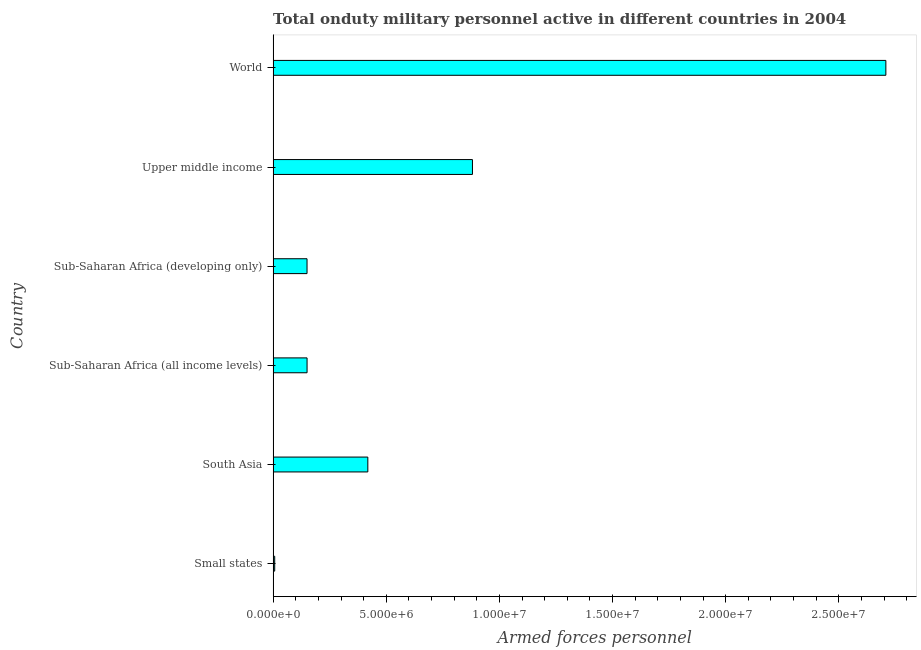Does the graph contain any zero values?
Make the answer very short. No. Does the graph contain grids?
Offer a terse response. No. What is the title of the graph?
Give a very brief answer. Total onduty military personnel active in different countries in 2004. What is the label or title of the X-axis?
Provide a succinct answer. Armed forces personnel. What is the label or title of the Y-axis?
Your response must be concise. Country. What is the number of armed forces personnel in Upper middle income?
Provide a short and direct response. 8.81e+06. Across all countries, what is the maximum number of armed forces personnel?
Your answer should be very brief. 2.71e+07. Across all countries, what is the minimum number of armed forces personnel?
Your answer should be compact. 7.01e+04. In which country was the number of armed forces personnel maximum?
Your answer should be compact. World. In which country was the number of armed forces personnel minimum?
Provide a succinct answer. Small states. What is the sum of the number of armed forces personnel?
Your answer should be very brief. 4.31e+07. What is the difference between the number of armed forces personnel in Sub-Saharan Africa (developing only) and World?
Provide a succinct answer. -2.56e+07. What is the average number of armed forces personnel per country?
Ensure brevity in your answer.  7.19e+06. What is the median number of armed forces personnel?
Ensure brevity in your answer.  2.84e+06. In how many countries, is the number of armed forces personnel greater than 2000000 ?
Your answer should be very brief. 3. What is the ratio of the number of armed forces personnel in South Asia to that in Upper middle income?
Keep it short and to the point. 0.47. Is the number of armed forces personnel in Small states less than that in Upper middle income?
Give a very brief answer. Yes. Is the difference between the number of armed forces personnel in Sub-Saharan Africa (all income levels) and Upper middle income greater than the difference between any two countries?
Make the answer very short. No. What is the difference between the highest and the second highest number of armed forces personnel?
Provide a short and direct response. 1.83e+07. Is the sum of the number of armed forces personnel in South Asia and Upper middle income greater than the maximum number of armed forces personnel across all countries?
Make the answer very short. No. What is the difference between the highest and the lowest number of armed forces personnel?
Your answer should be compact. 2.70e+07. How many bars are there?
Make the answer very short. 6. What is the Armed forces personnel in Small states?
Provide a succinct answer. 7.01e+04. What is the Armed forces personnel in South Asia?
Ensure brevity in your answer.  4.19e+06. What is the Armed forces personnel in Sub-Saharan Africa (all income levels)?
Provide a short and direct response. 1.50e+06. What is the Armed forces personnel of Sub-Saharan Africa (developing only)?
Make the answer very short. 1.50e+06. What is the Armed forces personnel in Upper middle income?
Your answer should be compact. 8.81e+06. What is the Armed forces personnel in World?
Provide a succinct answer. 2.71e+07. What is the difference between the Armed forces personnel in Small states and South Asia?
Offer a very short reply. -4.12e+06. What is the difference between the Armed forces personnel in Small states and Sub-Saharan Africa (all income levels)?
Provide a succinct answer. -1.43e+06. What is the difference between the Armed forces personnel in Small states and Sub-Saharan Africa (developing only)?
Give a very brief answer. -1.43e+06. What is the difference between the Armed forces personnel in Small states and Upper middle income?
Provide a short and direct response. -8.74e+06. What is the difference between the Armed forces personnel in Small states and World?
Your answer should be very brief. -2.70e+07. What is the difference between the Armed forces personnel in South Asia and Sub-Saharan Africa (all income levels)?
Ensure brevity in your answer.  2.69e+06. What is the difference between the Armed forces personnel in South Asia and Sub-Saharan Africa (developing only)?
Provide a short and direct response. 2.69e+06. What is the difference between the Armed forces personnel in South Asia and Upper middle income?
Offer a very short reply. -4.62e+06. What is the difference between the Armed forces personnel in South Asia and World?
Your answer should be very brief. -2.29e+07. What is the difference between the Armed forces personnel in Sub-Saharan Africa (all income levels) and Sub-Saharan Africa (developing only)?
Keep it short and to the point. 1650. What is the difference between the Armed forces personnel in Sub-Saharan Africa (all income levels) and Upper middle income?
Your answer should be very brief. -7.31e+06. What is the difference between the Armed forces personnel in Sub-Saharan Africa (all income levels) and World?
Your response must be concise. -2.56e+07. What is the difference between the Armed forces personnel in Sub-Saharan Africa (developing only) and Upper middle income?
Offer a terse response. -7.31e+06. What is the difference between the Armed forces personnel in Sub-Saharan Africa (developing only) and World?
Provide a succinct answer. -2.56e+07. What is the difference between the Armed forces personnel in Upper middle income and World?
Offer a very short reply. -1.83e+07. What is the ratio of the Armed forces personnel in Small states to that in South Asia?
Ensure brevity in your answer.  0.02. What is the ratio of the Armed forces personnel in Small states to that in Sub-Saharan Africa (all income levels)?
Offer a terse response. 0.05. What is the ratio of the Armed forces personnel in Small states to that in Sub-Saharan Africa (developing only)?
Your answer should be compact. 0.05. What is the ratio of the Armed forces personnel in Small states to that in Upper middle income?
Provide a succinct answer. 0.01. What is the ratio of the Armed forces personnel in Small states to that in World?
Offer a terse response. 0. What is the ratio of the Armed forces personnel in South Asia to that in Sub-Saharan Africa (all income levels)?
Offer a very short reply. 2.79. What is the ratio of the Armed forces personnel in South Asia to that in Sub-Saharan Africa (developing only)?
Keep it short and to the point. 2.79. What is the ratio of the Armed forces personnel in South Asia to that in Upper middle income?
Your answer should be very brief. 0.47. What is the ratio of the Armed forces personnel in South Asia to that in World?
Your response must be concise. 0.15. What is the ratio of the Armed forces personnel in Sub-Saharan Africa (all income levels) to that in Sub-Saharan Africa (developing only)?
Your answer should be very brief. 1. What is the ratio of the Armed forces personnel in Sub-Saharan Africa (all income levels) to that in Upper middle income?
Provide a succinct answer. 0.17. What is the ratio of the Armed forces personnel in Sub-Saharan Africa (all income levels) to that in World?
Offer a very short reply. 0.06. What is the ratio of the Armed forces personnel in Sub-Saharan Africa (developing only) to that in Upper middle income?
Your answer should be compact. 0.17. What is the ratio of the Armed forces personnel in Sub-Saharan Africa (developing only) to that in World?
Your answer should be very brief. 0.06. What is the ratio of the Armed forces personnel in Upper middle income to that in World?
Give a very brief answer. 0.33. 